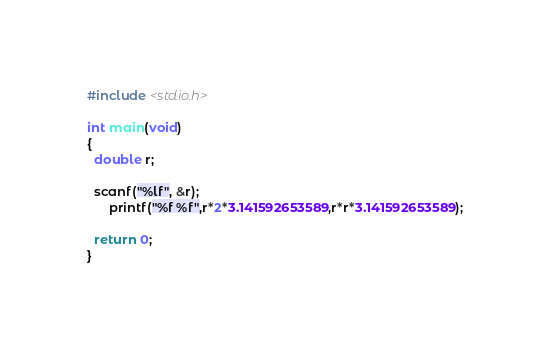<code> <loc_0><loc_0><loc_500><loc_500><_C++_>#include <stdio.h>
 
int main(void)
{
  double r;
 
  scanf("%lf", &r);
      printf("%f %f",r*2*3.141592653589,r*r*3.141592653589);
 
  return 0;
}</code> 